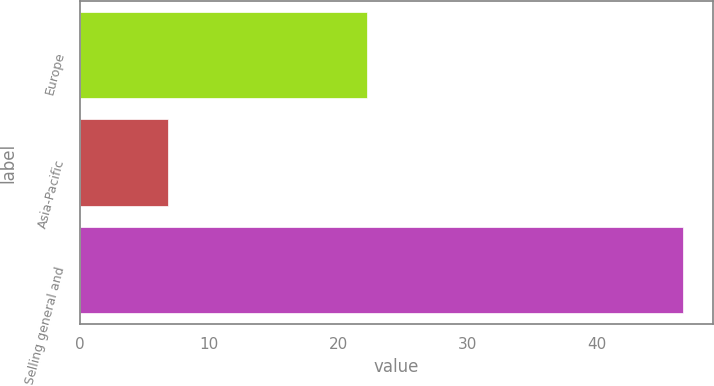Convert chart to OTSL. <chart><loc_0><loc_0><loc_500><loc_500><bar_chart><fcel>Europe<fcel>Asia-Pacific<fcel>Selling general and<nl><fcel>22.2<fcel>6.8<fcel>46.7<nl></chart> 